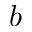Convert formula to latex. <formula><loc_0><loc_0><loc_500><loc_500>b</formula> 